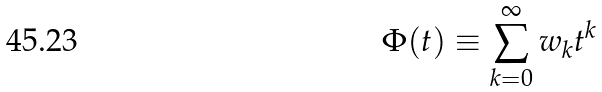Convert formula to latex. <formula><loc_0><loc_0><loc_500><loc_500>\Phi ( t ) \equiv \sum _ { k = 0 } ^ { \infty } w _ { k } t ^ { k }</formula> 